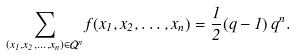<formula> <loc_0><loc_0><loc_500><loc_500>\sum _ { ( x _ { 1 } , x _ { 2 } , \dots , x _ { n } ) \in { \mathcal { Q } } ^ { n } } f ( x _ { 1 } , x _ { 2 } , \dots , x _ { n } ) = \frac { 1 } { 2 } ( q - 1 ) \, q ^ { n } .</formula> 